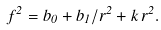<formula> <loc_0><loc_0><loc_500><loc_500>f ^ { 2 } = b _ { 0 } + b _ { 1 } / r ^ { 2 } + k \, r ^ { 2 } .</formula> 